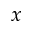Convert formula to latex. <formula><loc_0><loc_0><loc_500><loc_500>x</formula> 